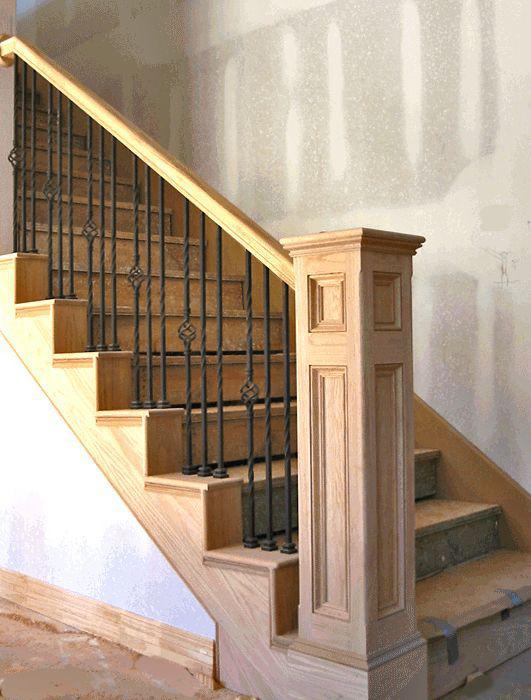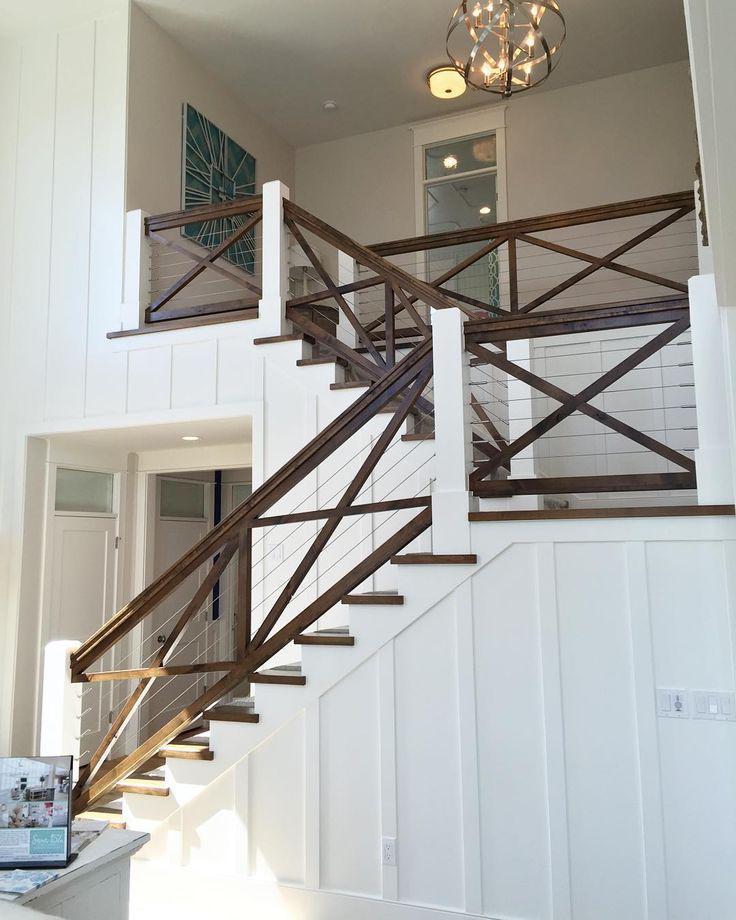The first image is the image on the left, the second image is the image on the right. Given the left and right images, does the statement "One of the stair's bannisters ends in a large, light brown colored wooden post." hold true? Answer yes or no. Yes. The first image is the image on the left, the second image is the image on the right. Assess this claim about the two images: "The left image shows a leftward-ascending staircase with a square light-colored wood-grain post at the bottom.". Correct or not? Answer yes or no. Yes. 